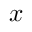Convert formula to latex. <formula><loc_0><loc_0><loc_500><loc_500>x _ { \, }</formula> 